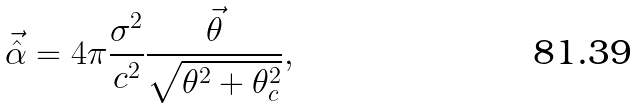<formula> <loc_0><loc_0><loc_500><loc_500>\vec { \hat { \alpha } } = 4 \pi \frac { \sigma ^ { 2 } } { c ^ { 2 } } \frac { \vec { \theta } } { \sqrt { \theta ^ { 2 } + \theta _ { c } ^ { 2 } } } ,</formula> 